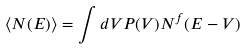<formula> <loc_0><loc_0><loc_500><loc_500>\left \langle N ( E ) \right \rangle = \int d V P ( V ) N ^ { f } ( E - V )</formula> 